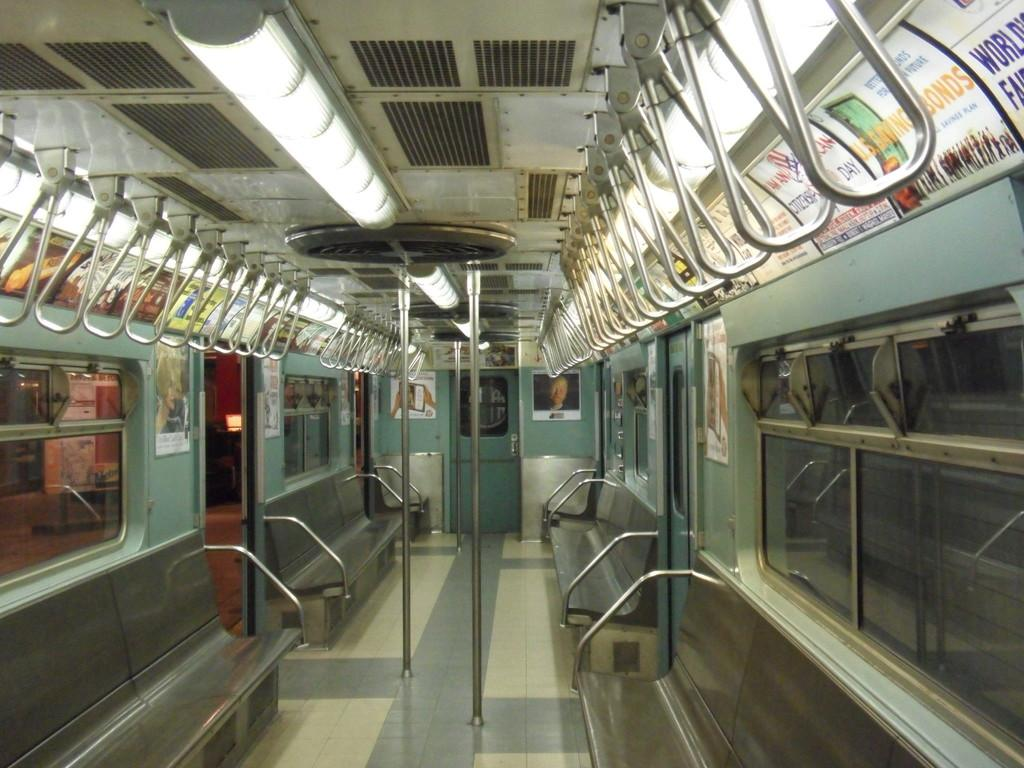Where is the image taken? The image is inside a train. What can be found inside the train? There are seats, handles, poles, posters on the walls, ceiling lights, and glass windows. What can be seen through the windows? The platform is visible through the windows. What type of agreement is being discussed by the passengers in the image? There are no passengers visible in the image, and therefore no agreement is being discussed. What material is the metal pole made of in the image? There is no metal pole present in the image. 